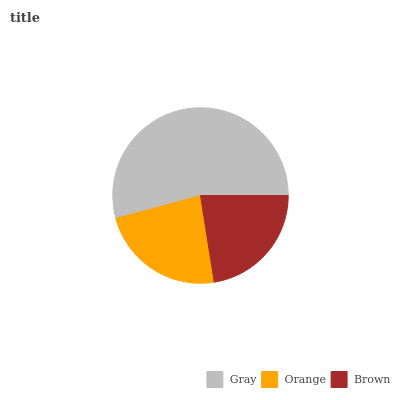Is Brown the minimum?
Answer yes or no. Yes. Is Gray the maximum?
Answer yes or no. Yes. Is Orange the minimum?
Answer yes or no. No. Is Orange the maximum?
Answer yes or no. No. Is Gray greater than Orange?
Answer yes or no. Yes. Is Orange less than Gray?
Answer yes or no. Yes. Is Orange greater than Gray?
Answer yes or no. No. Is Gray less than Orange?
Answer yes or no. No. Is Orange the high median?
Answer yes or no. Yes. Is Orange the low median?
Answer yes or no. Yes. Is Brown the high median?
Answer yes or no. No. Is Gray the low median?
Answer yes or no. No. 